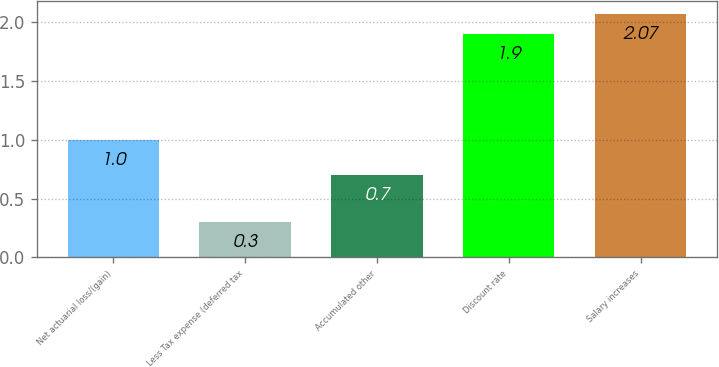<chart> <loc_0><loc_0><loc_500><loc_500><bar_chart><fcel>Net actuarial loss/(gain)<fcel>Less Tax expense (deferred tax<fcel>Accumulated other<fcel>Discount rate<fcel>Salary increases<nl><fcel>1<fcel>0.3<fcel>0.7<fcel>1.9<fcel>2.07<nl></chart> 